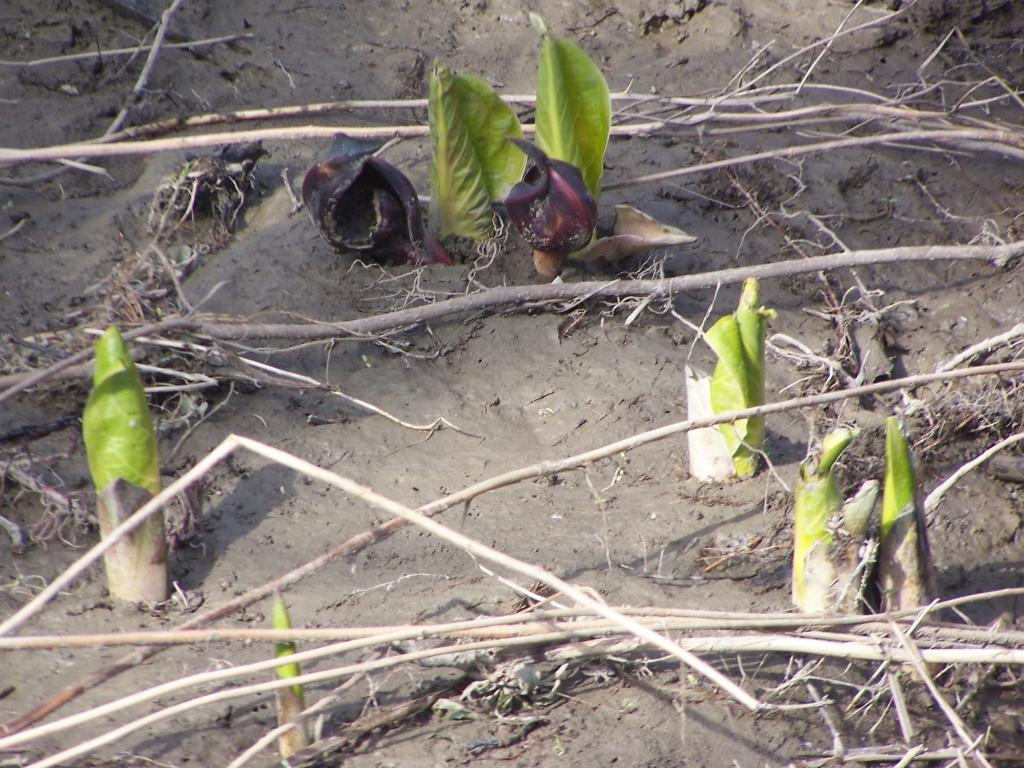What type of vegetation is present in the image? There are green leaves in the image. Where are the green leaves located? The green leaves are on the land. What else can be seen on the land in the image? There are wood stems in the image. Where are the wood stems located? The wood stems are on the land. What type of crayon can be seen melting in the image? There is no crayon present in the image, and therefore no such activity can be observed. 